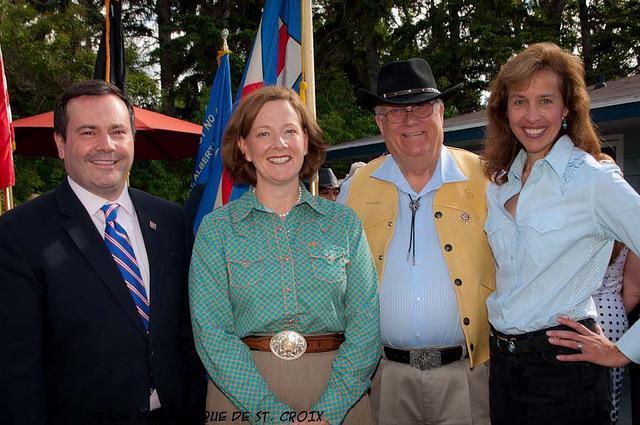How many flags are in the background?
Give a very brief answer. 4. How many people are there?
Give a very brief answer. 4. 